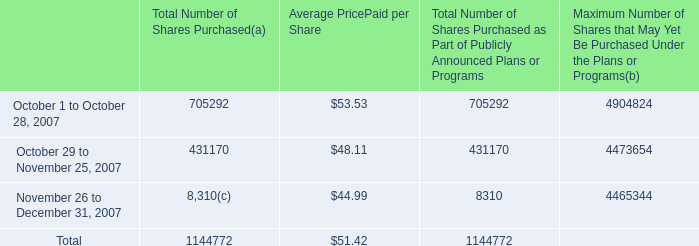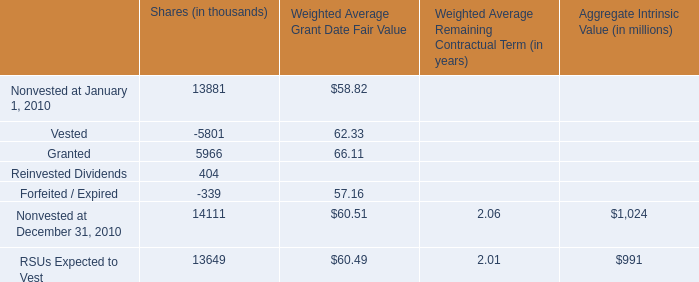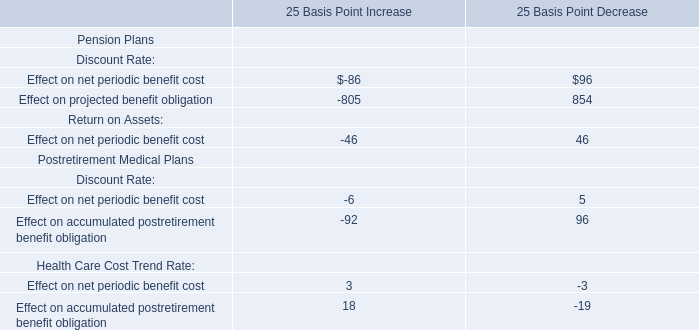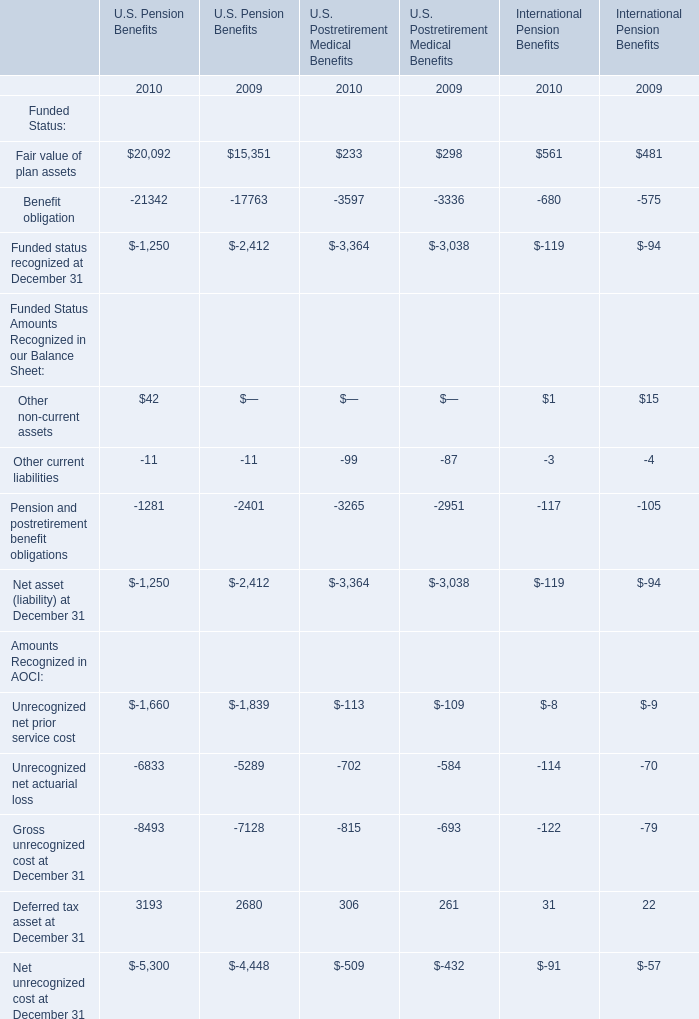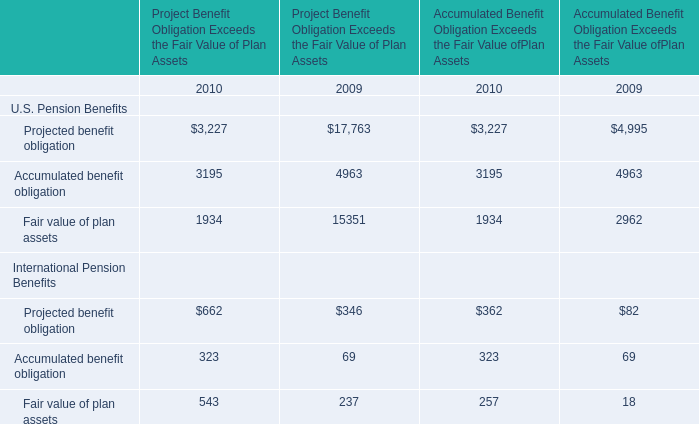What's the current growth rate of Fair value of plan assets of U.S. pension benefits for Accumulated Benefit Obligation Exceeds the Fair Value of Plan Assets? 
Computations: ((1934 - 2962) / 2962)
Answer: -0.34706. 